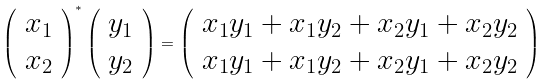<formula> <loc_0><loc_0><loc_500><loc_500>\left ( \begin{array} { c } x _ { 1 } \\ x _ { 2 } \end{array} \right ) ^ { * } \left ( \begin{array} { c } y _ { 1 } \\ y _ { 2 } \end{array} \right ) = \left ( \begin{array} { c } x _ { 1 } y _ { 1 } + x _ { 1 } y _ { 2 } + x _ { 2 } y _ { 1 } + x _ { 2 } y _ { 2 } \\ x _ { 1 } y _ { 1 } + x _ { 1 } y _ { 2 } + x _ { 2 } y _ { 1 } + x _ { 2 } y _ { 2 } \end{array} \right )</formula> 